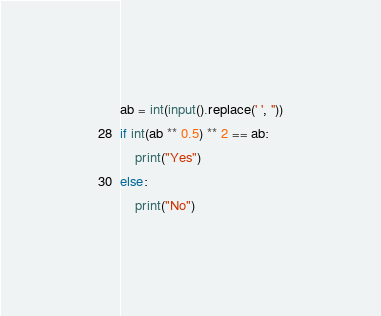<code> <loc_0><loc_0><loc_500><loc_500><_Python_>ab = int(input().replace(' ', ''))
if int(ab ** 0.5) ** 2 == ab:
    print("Yes")
else:
    print("No")</code> 